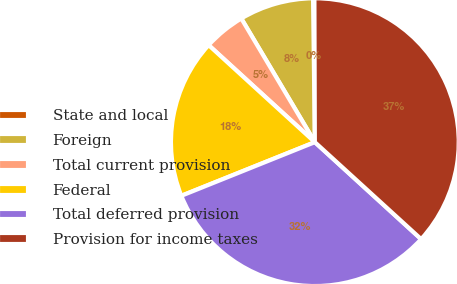<chart> <loc_0><loc_0><loc_500><loc_500><pie_chart><fcel>State and local<fcel>Foreign<fcel>Total current provision<fcel>Federal<fcel>Total deferred provision<fcel>Provision for income taxes<nl><fcel>0.15%<fcel>8.34%<fcel>4.68%<fcel>17.86%<fcel>32.15%<fcel>36.82%<nl></chart> 